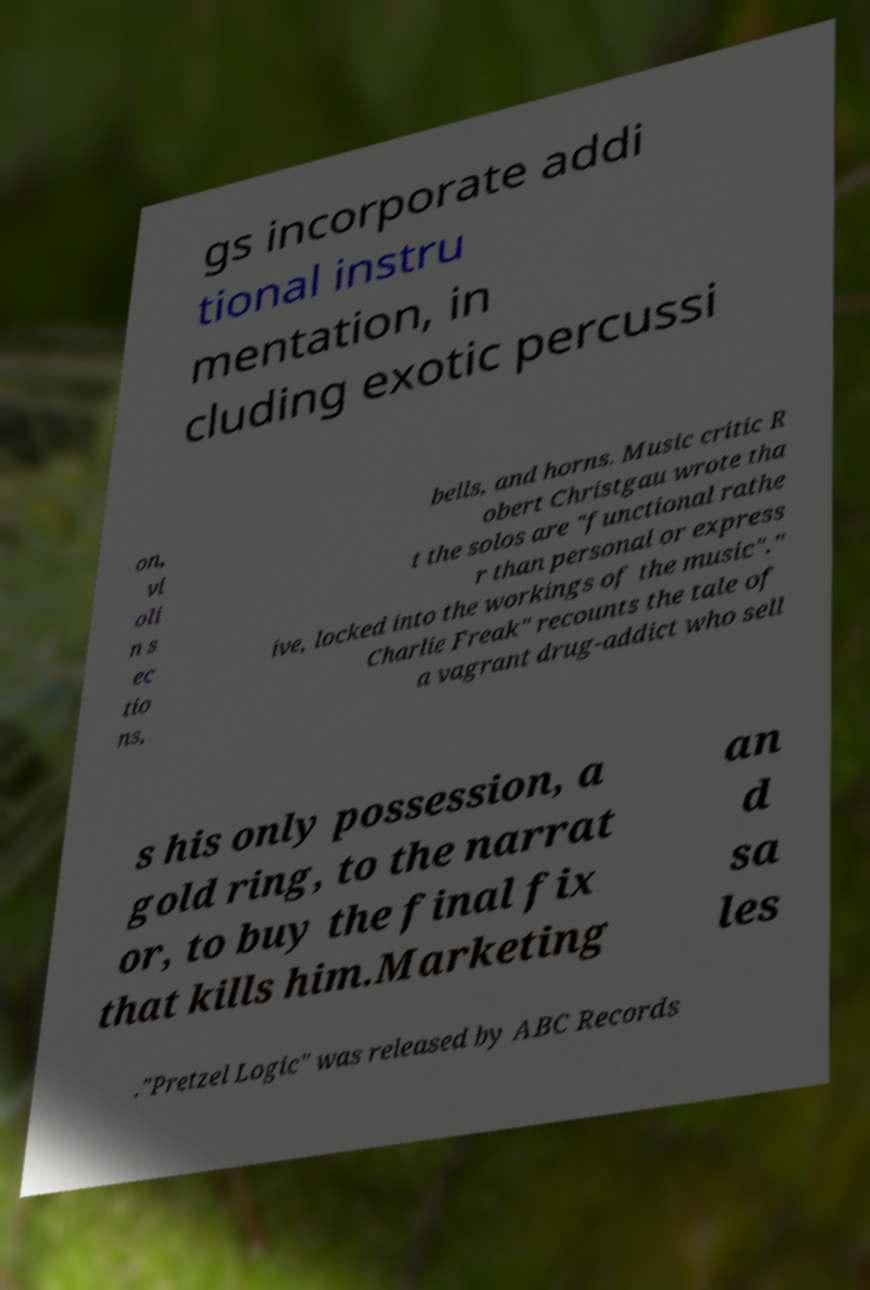For documentation purposes, I need the text within this image transcribed. Could you provide that? gs incorporate addi tional instru mentation, in cluding exotic percussi on, vi oli n s ec tio ns, bells, and horns. Music critic R obert Christgau wrote tha t the solos are "functional rathe r than personal or express ive, locked into the workings of the music"." Charlie Freak" recounts the tale of a vagrant drug-addict who sell s his only possession, a gold ring, to the narrat or, to buy the final fix that kills him.Marketing an d sa les ."Pretzel Logic" was released by ABC Records 